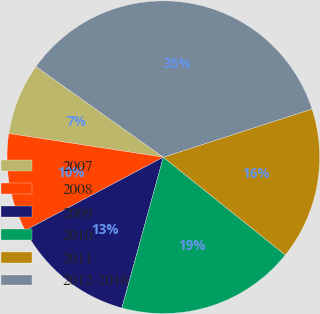Convert chart to OTSL. <chart><loc_0><loc_0><loc_500><loc_500><pie_chart><fcel>2007<fcel>2008<fcel>2009<fcel>2010<fcel>2011<fcel>2012-2016<nl><fcel>7.42%<fcel>10.19%<fcel>12.97%<fcel>18.52%<fcel>15.74%<fcel>35.17%<nl></chart> 